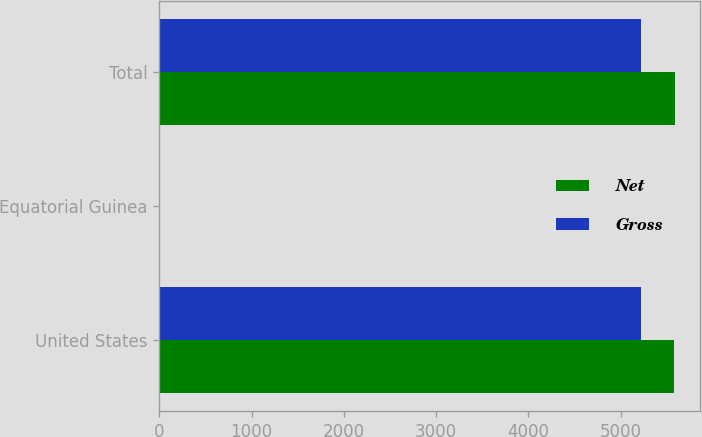Convert chart. <chart><loc_0><loc_0><loc_500><loc_500><stacked_bar_chart><ecel><fcel>United States<fcel>Equatorial Guinea<fcel>Total<nl><fcel>Net<fcel>5580<fcel>5<fcel>5585<nl><fcel>Gross<fcel>5222<fcel>2<fcel>5224<nl></chart> 